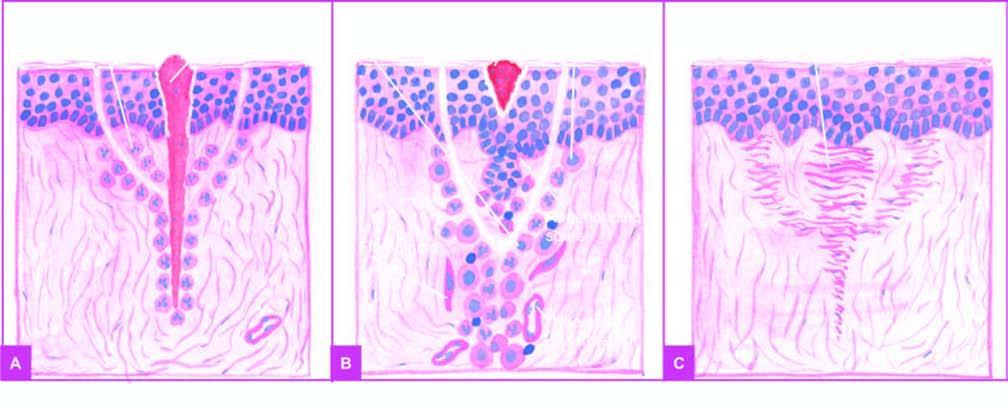s the alveolar septa inflammatory response from the margins?
Answer the question using a single word or phrase. No 